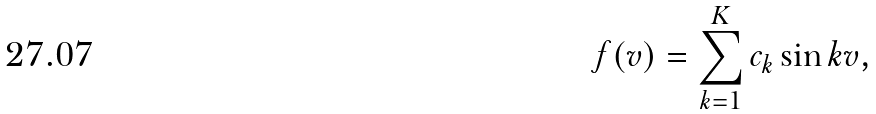<formula> <loc_0><loc_0><loc_500><loc_500>f ( v ) = \sum _ { k = 1 } ^ { K } c _ { k } \sin k v ,</formula> 